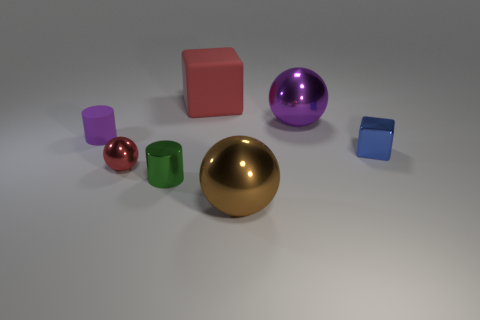Is there a big metal sphere that has the same color as the small ball?
Your answer should be compact. No. Are there fewer tiny red balls than things?
Offer a terse response. Yes. What number of objects are small blocks or big shiny balls that are behind the tiny red metallic object?
Provide a succinct answer. 2. Are there any red blocks that have the same material as the tiny blue cube?
Provide a short and direct response. No. What is the material of the brown sphere that is the same size as the matte block?
Ensure brevity in your answer.  Metal. What is the material of the red object that is on the left side of the red object that is behind the tiny red metal object?
Your response must be concise. Metal. Is the shape of the big object that is in front of the green shiny cylinder the same as  the tiny red thing?
Your answer should be very brief. Yes. What is the color of the tiny cylinder that is made of the same material as the red cube?
Your answer should be compact. Purple. What is the large sphere behind the red shiny ball made of?
Make the answer very short. Metal. Do the purple metal object and the small metallic object right of the red matte block have the same shape?
Ensure brevity in your answer.  No. 